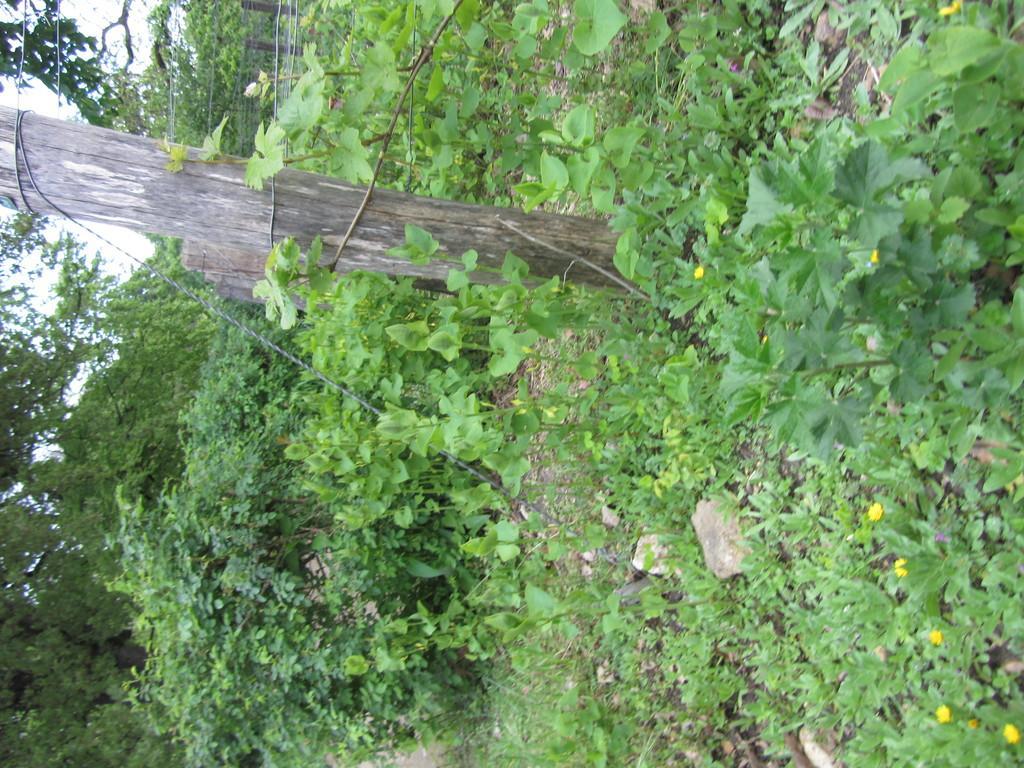In one or two sentences, can you explain what this image depicts? It is a tilted image there is a wooden pole fencing, around that fencing there are many plants and trees. 